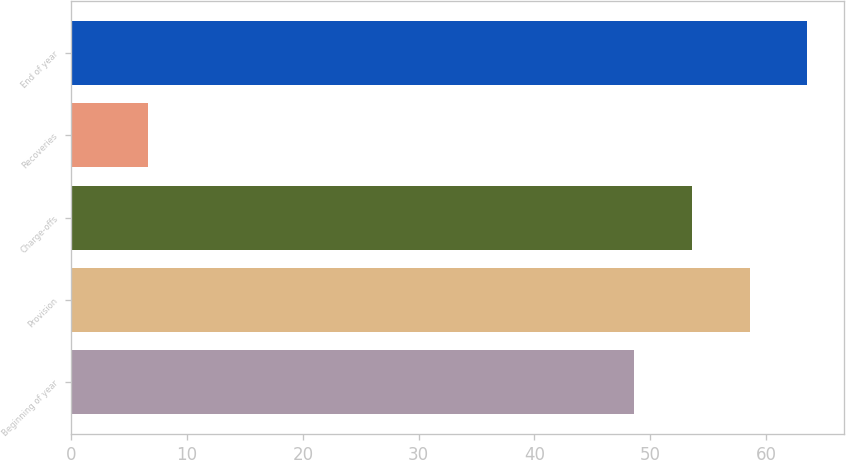Convert chart to OTSL. <chart><loc_0><loc_0><loc_500><loc_500><bar_chart><fcel>Beginning of year<fcel>Provision<fcel>Charge-offs<fcel>Recoveries<fcel>End of year<nl><fcel>48.6<fcel>58.58<fcel>53.59<fcel>6.6<fcel>63.57<nl></chart> 